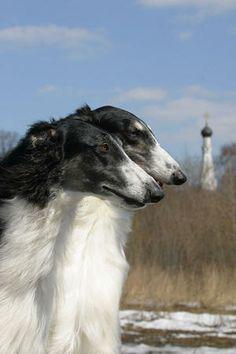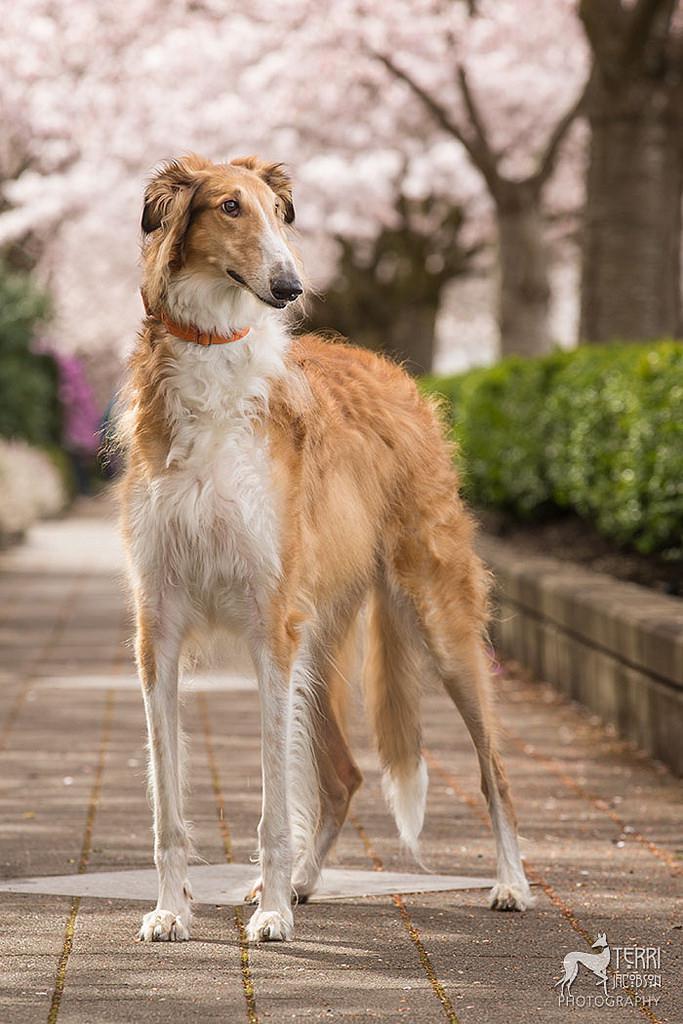The first image is the image on the left, the second image is the image on the right. Assess this claim about the two images: "One image shows two hounds with similar coloration.". Correct or not? Answer yes or no. Yes. 